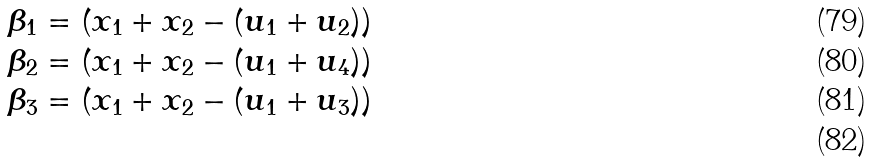Convert formula to latex. <formula><loc_0><loc_0><loc_500><loc_500>\beta _ { 1 } & = ( x _ { 1 } + x _ { 2 } - ( u _ { 1 } + u _ { 2 } ) ) \\ \beta _ { 2 } & = ( x _ { 1 } + x _ { 2 } - ( u _ { 1 } + u _ { 4 } ) ) \\ \beta _ { 3 } & = ( x _ { 1 } + x _ { 2 } - ( u _ { 1 } + u _ { 3 } ) ) \\</formula> 